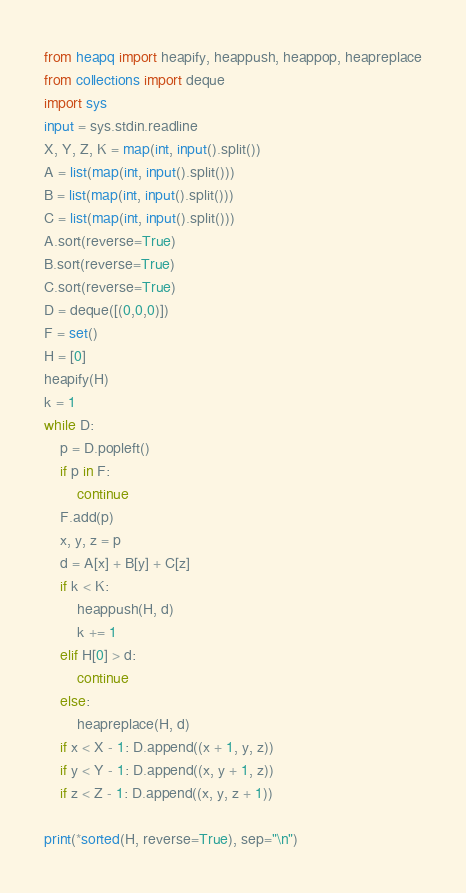Convert code to text. <code><loc_0><loc_0><loc_500><loc_500><_Python_>from heapq import heapify, heappush, heappop, heapreplace
from collections import deque
import sys
input = sys.stdin.readline
X, Y, Z, K = map(int, input().split())
A = list(map(int, input().split()))
B = list(map(int, input().split()))
C = list(map(int, input().split()))
A.sort(reverse=True)
B.sort(reverse=True)
C.sort(reverse=True)
D = deque([(0,0,0)])
F = set()
H = [0]
heapify(H)
k = 1
while D:
    p = D.popleft()
    if p in F:
        continue
    F.add(p)
    x, y, z = p
    d = A[x] + B[y] + C[z]
    if k < K:
        heappush(H, d)
        k += 1
    elif H[0] > d:
        continue
    else:
        heapreplace(H, d)
    if x < X - 1: D.append((x + 1, y, z))
    if y < Y - 1: D.append((x, y + 1, z))
    if z < Z - 1: D.append((x, y, z + 1))

print(*sorted(H, reverse=True), sep="\n")</code> 